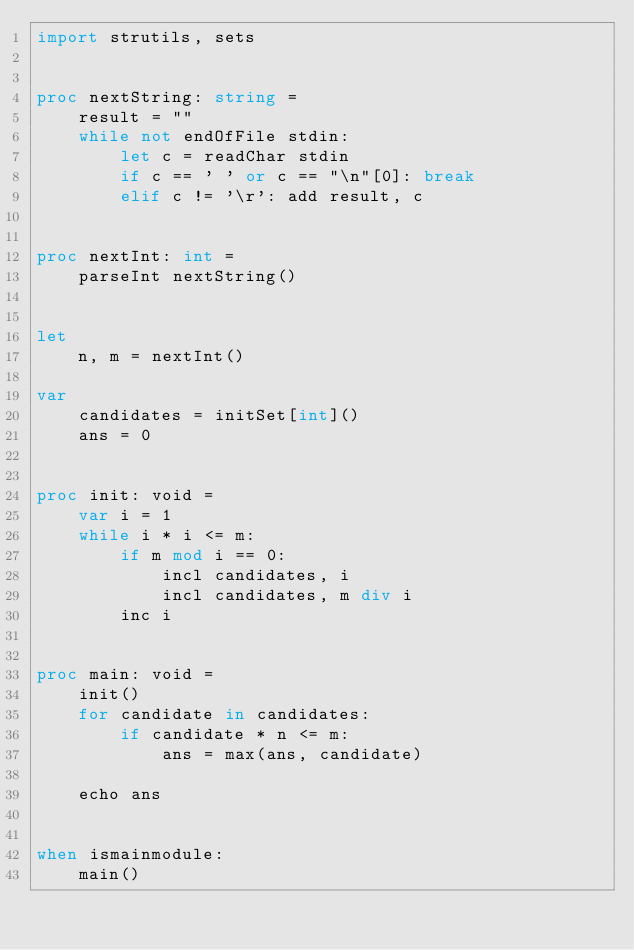Convert code to text. <code><loc_0><loc_0><loc_500><loc_500><_Nim_>import strutils, sets


proc nextString: string =
    result = ""
    while not endOfFile stdin:
        let c = readChar stdin
        if c == ' ' or c == "\n"[0]: break
        elif c != '\r': add result, c


proc nextInt: int =
    parseInt nextString()


let
    n, m = nextInt()

var
    candidates = initSet[int]()
    ans = 0


proc init: void =
    var i = 1
    while i * i <= m:
        if m mod i == 0:
            incl candidates, i
            incl candidates, m div i
        inc i


proc main: void =
    init()
    for candidate in candidates:
        if candidate * n <= m:
            ans = max(ans, candidate)
    
    echo ans


when ismainmodule:
    main()
</code> 